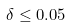Convert formula to latex. <formula><loc_0><loc_0><loc_500><loc_500>\delta \leq 0 . 0 5</formula> 